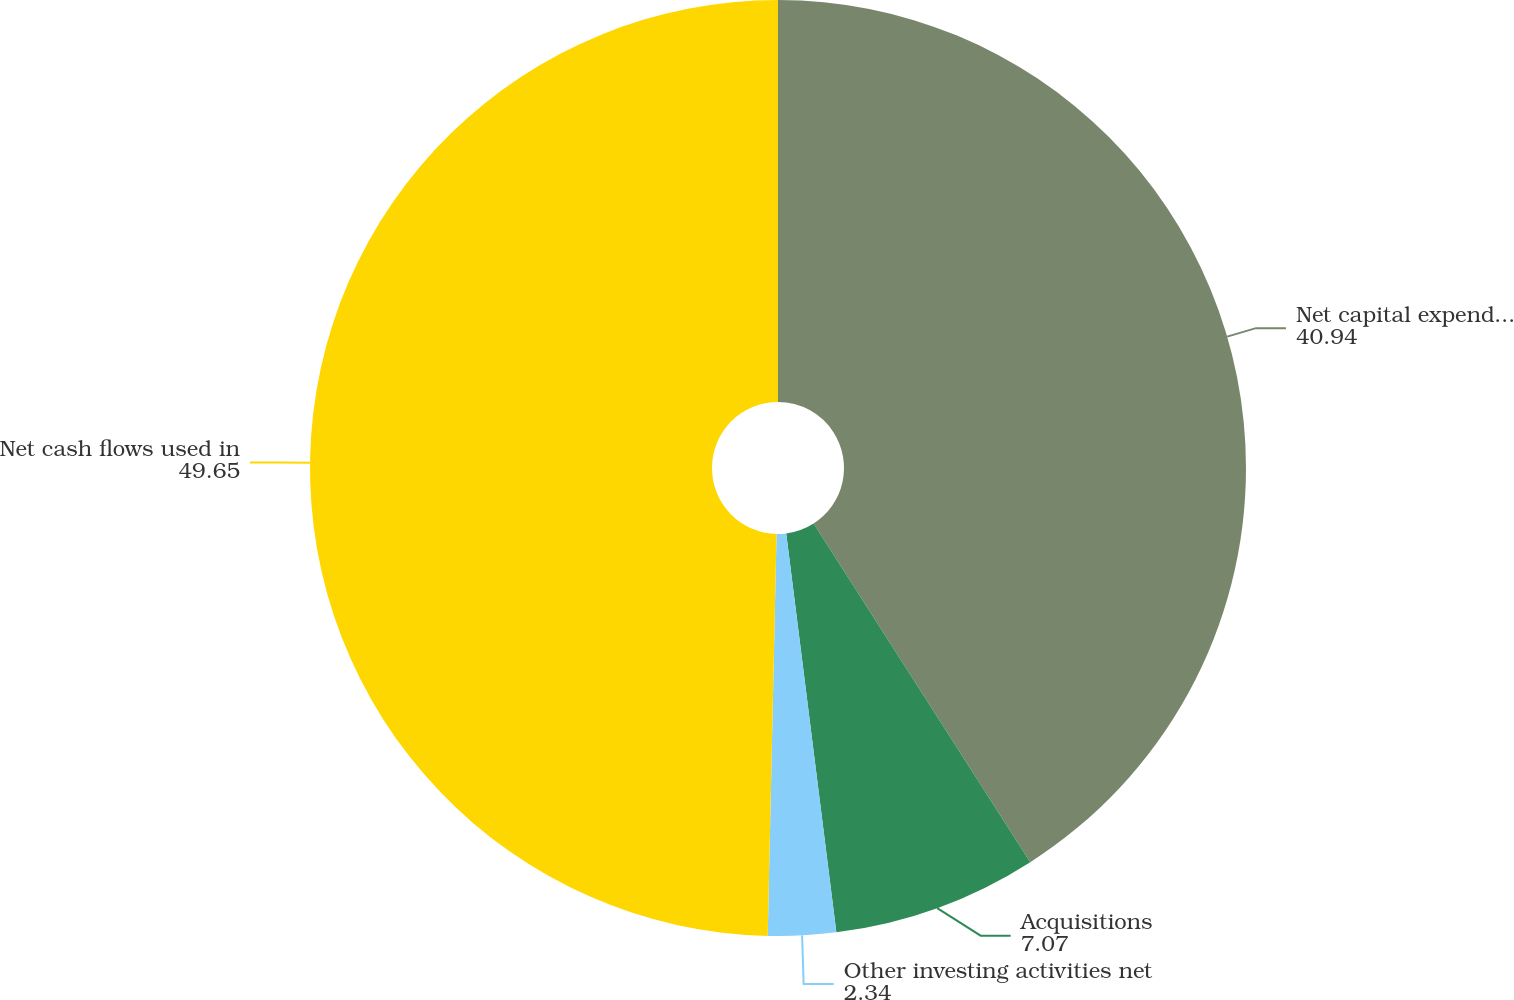Convert chart. <chart><loc_0><loc_0><loc_500><loc_500><pie_chart><fcel>Net capital expenditures<fcel>Acquisitions<fcel>Other investing activities net<fcel>Net cash flows used in<nl><fcel>40.94%<fcel>7.07%<fcel>2.34%<fcel>49.65%<nl></chart> 